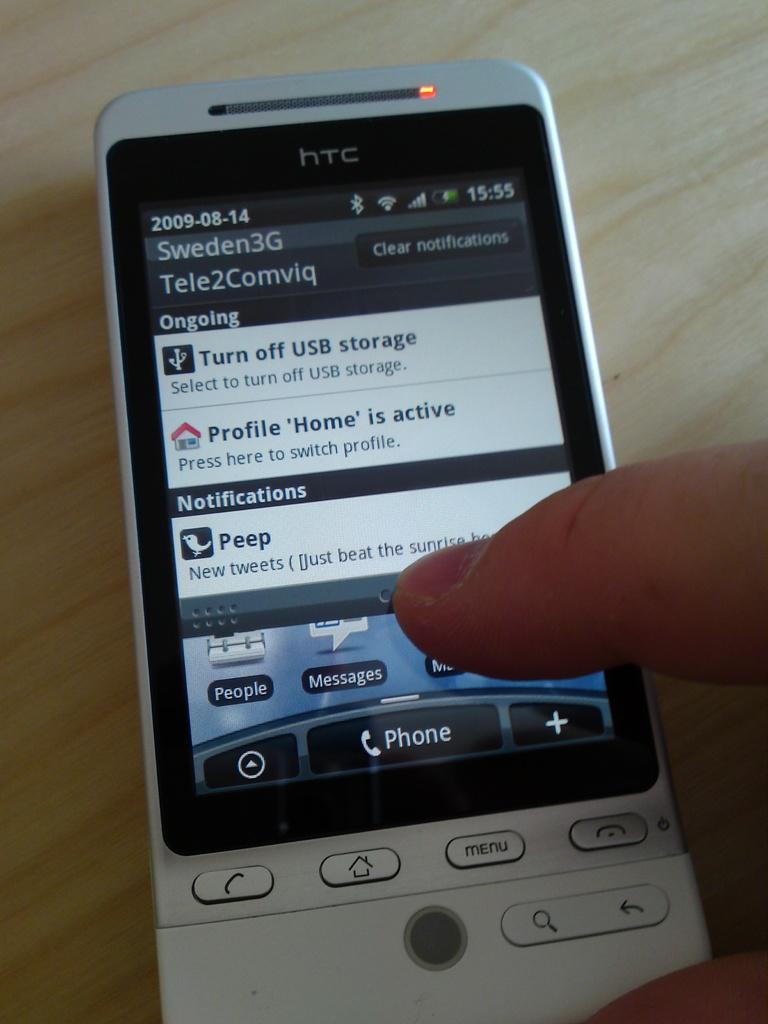<image>
Present a compact description of the photo's key features. An HTC mobile is seen in close up on the settings screen. 